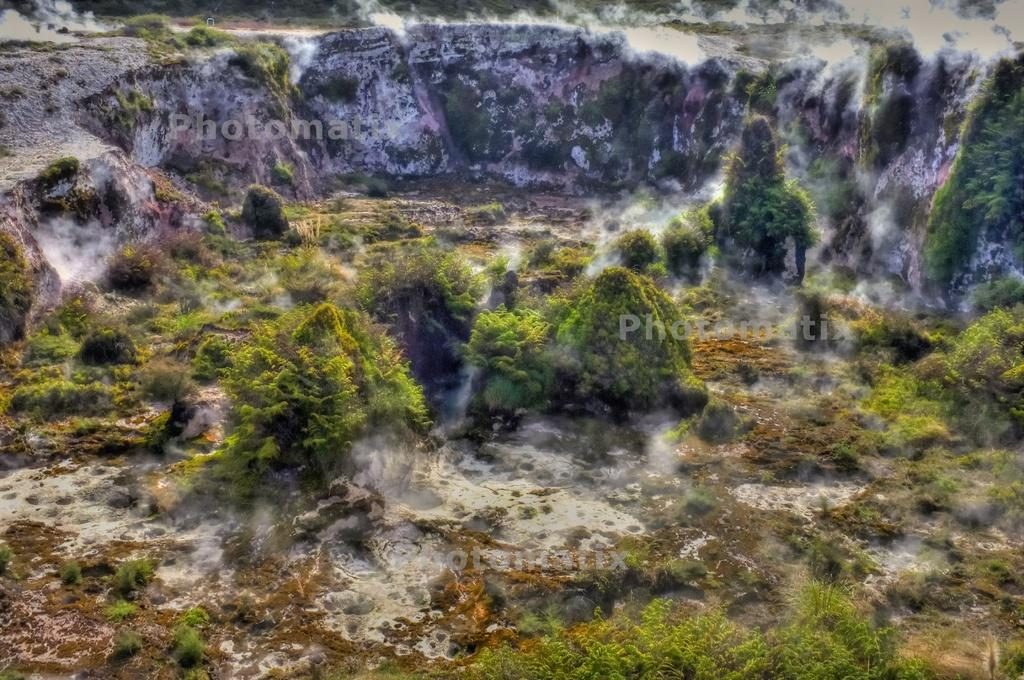What type of surface can be seen in the image? There is ground visible in the image. What type of vegetation is present in the image? There are trees in the image. What else can be seen in the image besides the ground and trees? There is smoke in the image. What type of afterthought is being expressed by the trees in the image? There is no indication of an afterthought being expressed by the trees in the image; they are simply trees. What type of operation is being performed on the smoke in the image? There is no operation being performed on the smoke in the image; it is simply visible. 